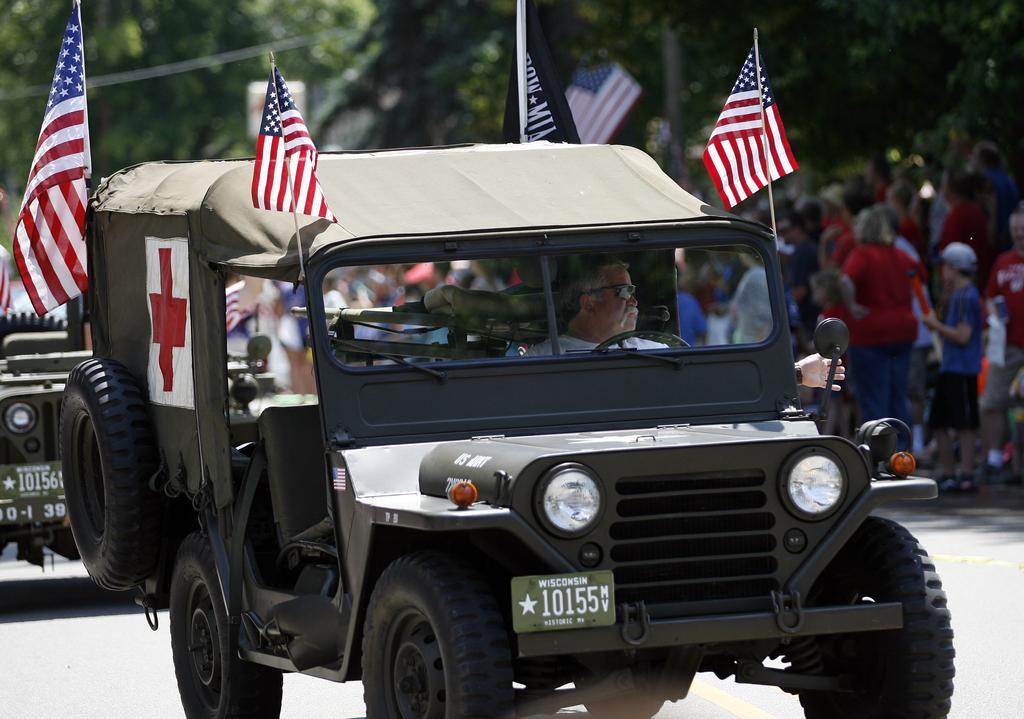In one or two sentences, can you explain what this image depicts? In this image there is a jeep and in jeep there is a number plate ,headlight , flag, tyre , attached to it and there is person who is riding the jeep and in the back ground there are group of people walking in the street , there is another jeep , tree. 